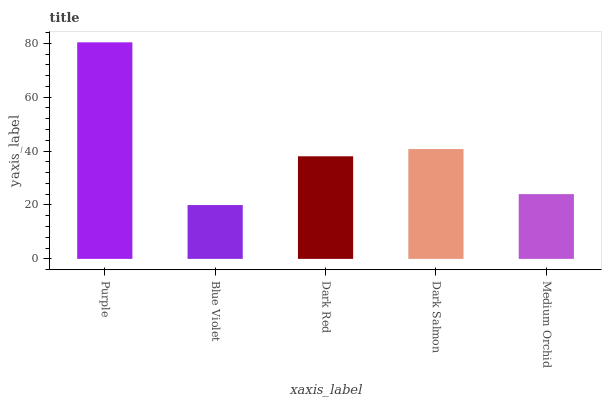Is Blue Violet the minimum?
Answer yes or no. Yes. Is Purple the maximum?
Answer yes or no. Yes. Is Dark Red the minimum?
Answer yes or no. No. Is Dark Red the maximum?
Answer yes or no. No. Is Dark Red greater than Blue Violet?
Answer yes or no. Yes. Is Blue Violet less than Dark Red?
Answer yes or no. Yes. Is Blue Violet greater than Dark Red?
Answer yes or no. No. Is Dark Red less than Blue Violet?
Answer yes or no. No. Is Dark Red the high median?
Answer yes or no. Yes. Is Dark Red the low median?
Answer yes or no. Yes. Is Medium Orchid the high median?
Answer yes or no. No. Is Purple the low median?
Answer yes or no. No. 